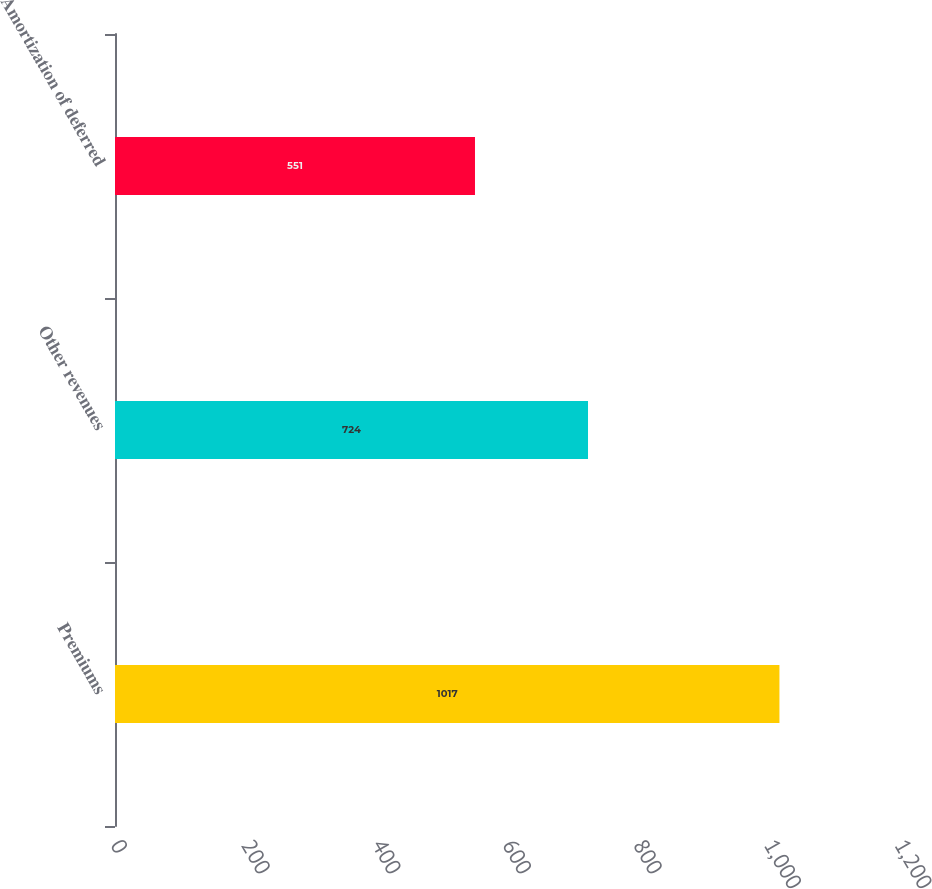Convert chart to OTSL. <chart><loc_0><loc_0><loc_500><loc_500><bar_chart><fcel>Premiums<fcel>Other revenues<fcel>Amortization of deferred<nl><fcel>1017<fcel>724<fcel>551<nl></chart> 